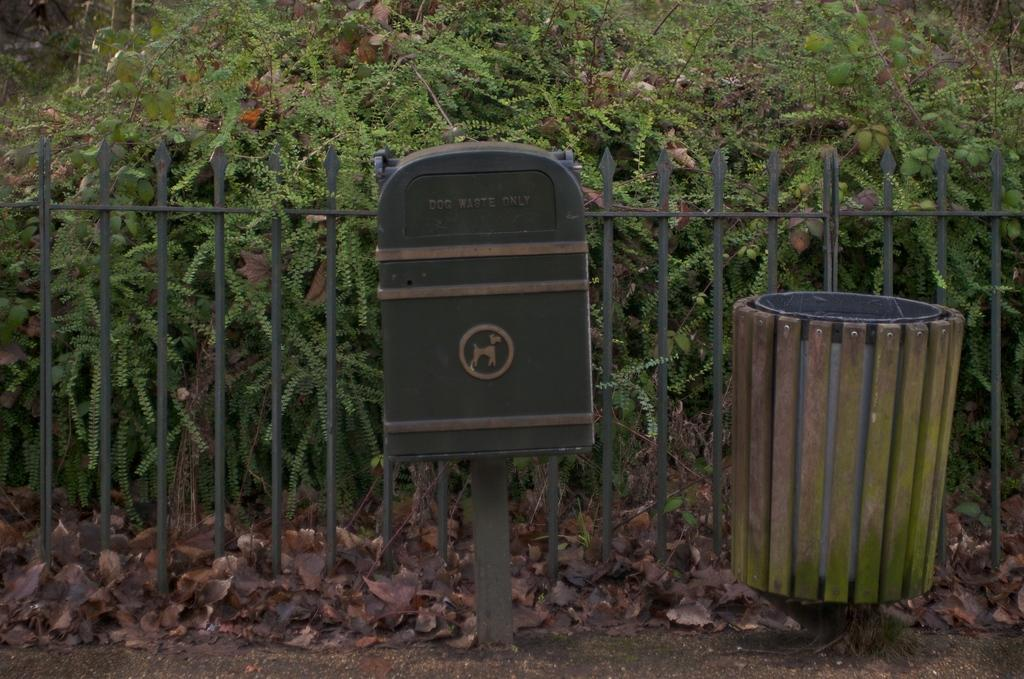Provide a one-sentence caption for the provided image. A DOG WASTE ONLY container sits next to a garbage bin. 